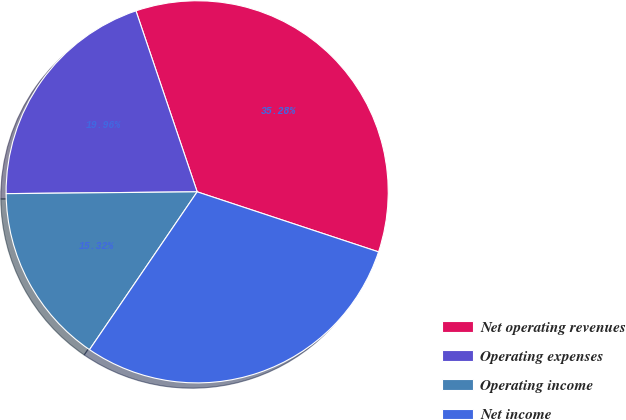Convert chart. <chart><loc_0><loc_0><loc_500><loc_500><pie_chart><fcel>Net operating revenues<fcel>Operating expenses<fcel>Operating income<fcel>Net income<nl><fcel>35.28%<fcel>19.96%<fcel>15.32%<fcel>29.44%<nl></chart> 